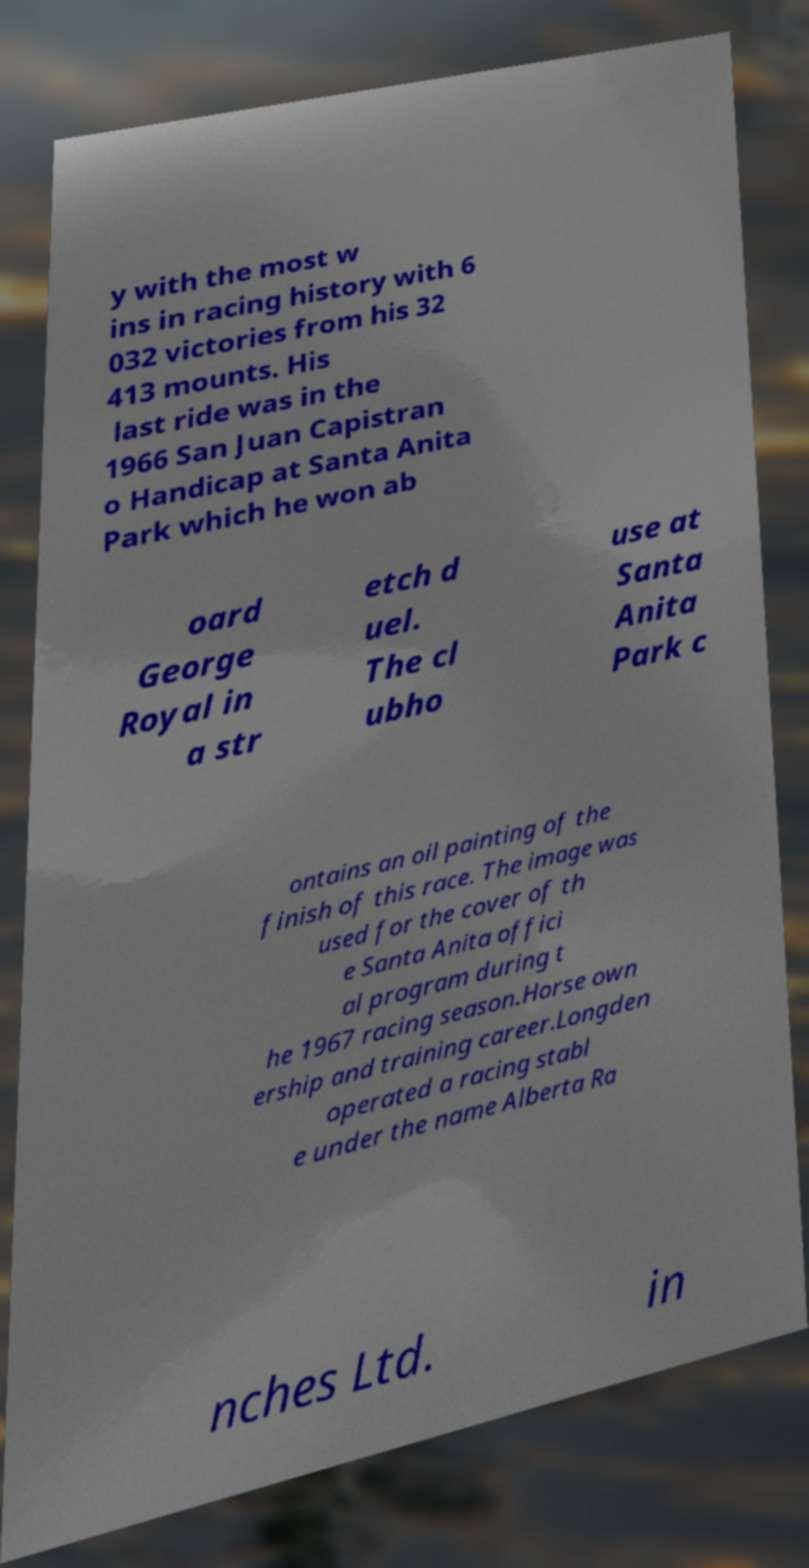Please identify and transcribe the text found in this image. y with the most w ins in racing history with 6 032 victories from his 32 413 mounts. His last ride was in the 1966 San Juan Capistran o Handicap at Santa Anita Park which he won ab oard George Royal in a str etch d uel. The cl ubho use at Santa Anita Park c ontains an oil painting of the finish of this race. The image was used for the cover of th e Santa Anita offici al program during t he 1967 racing season.Horse own ership and training career.Longden operated a racing stabl e under the name Alberta Ra nches Ltd. in 